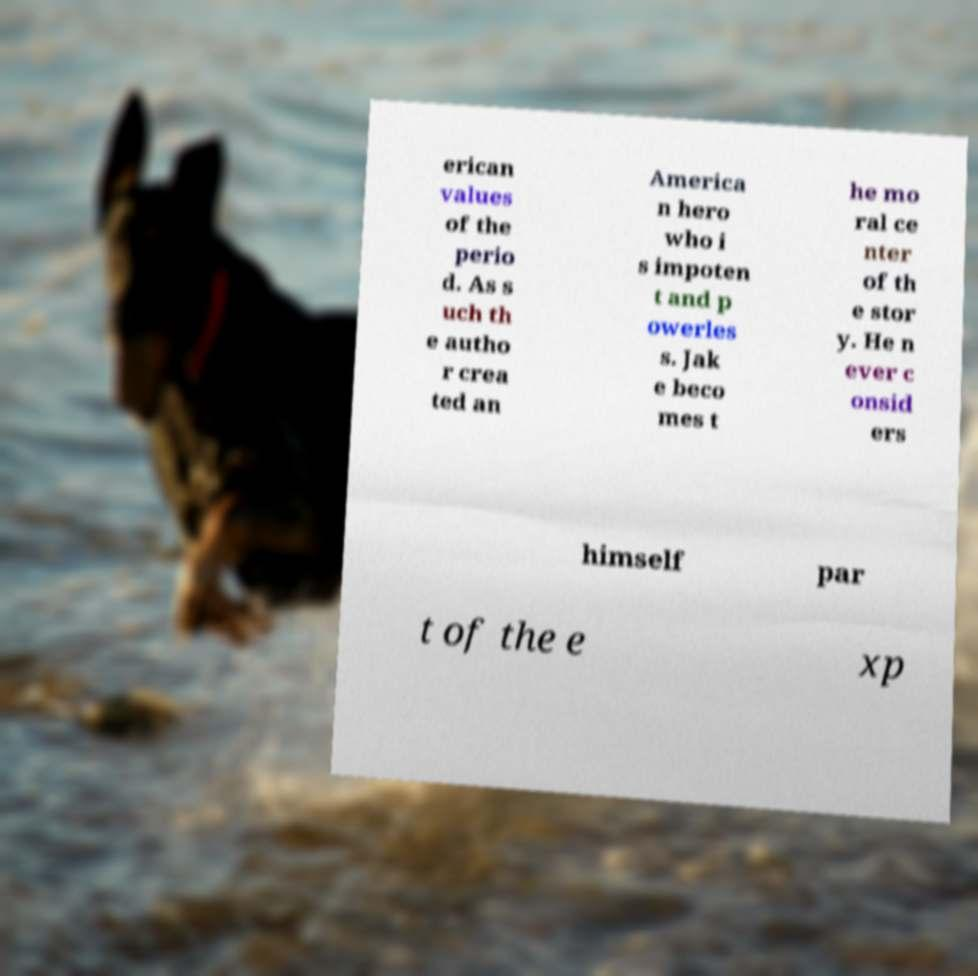Please read and relay the text visible in this image. What does it say? erican values of the perio d. As s uch th e autho r crea ted an America n hero who i s impoten t and p owerles s. Jak e beco mes t he mo ral ce nter of th e stor y. He n ever c onsid ers himself par t of the e xp 